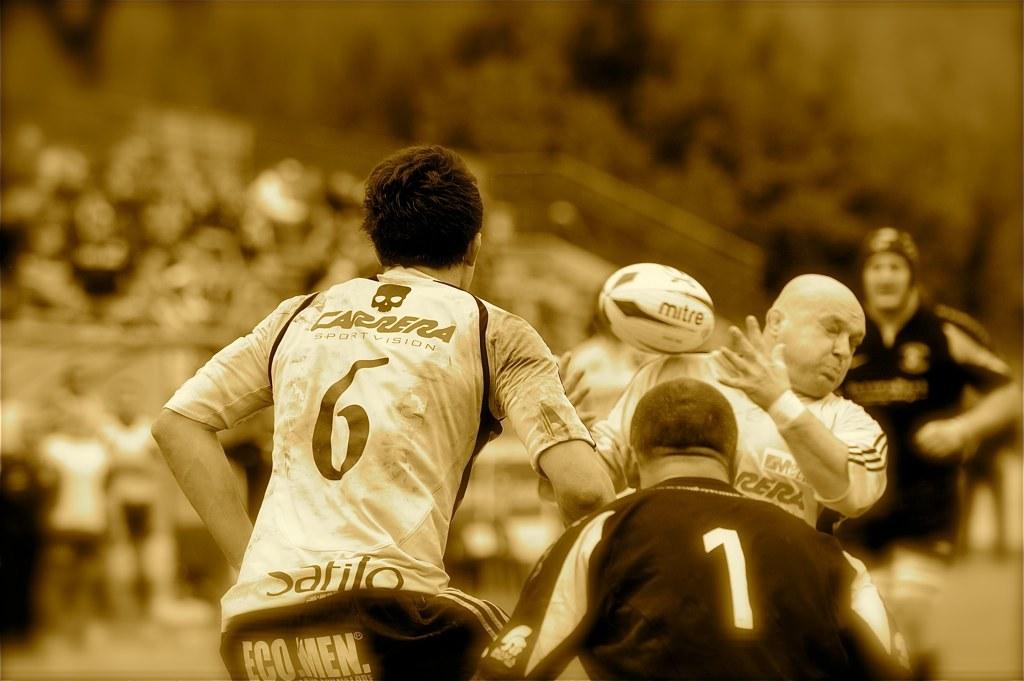What number is on the white jersey?
Provide a short and direct response. 6. 